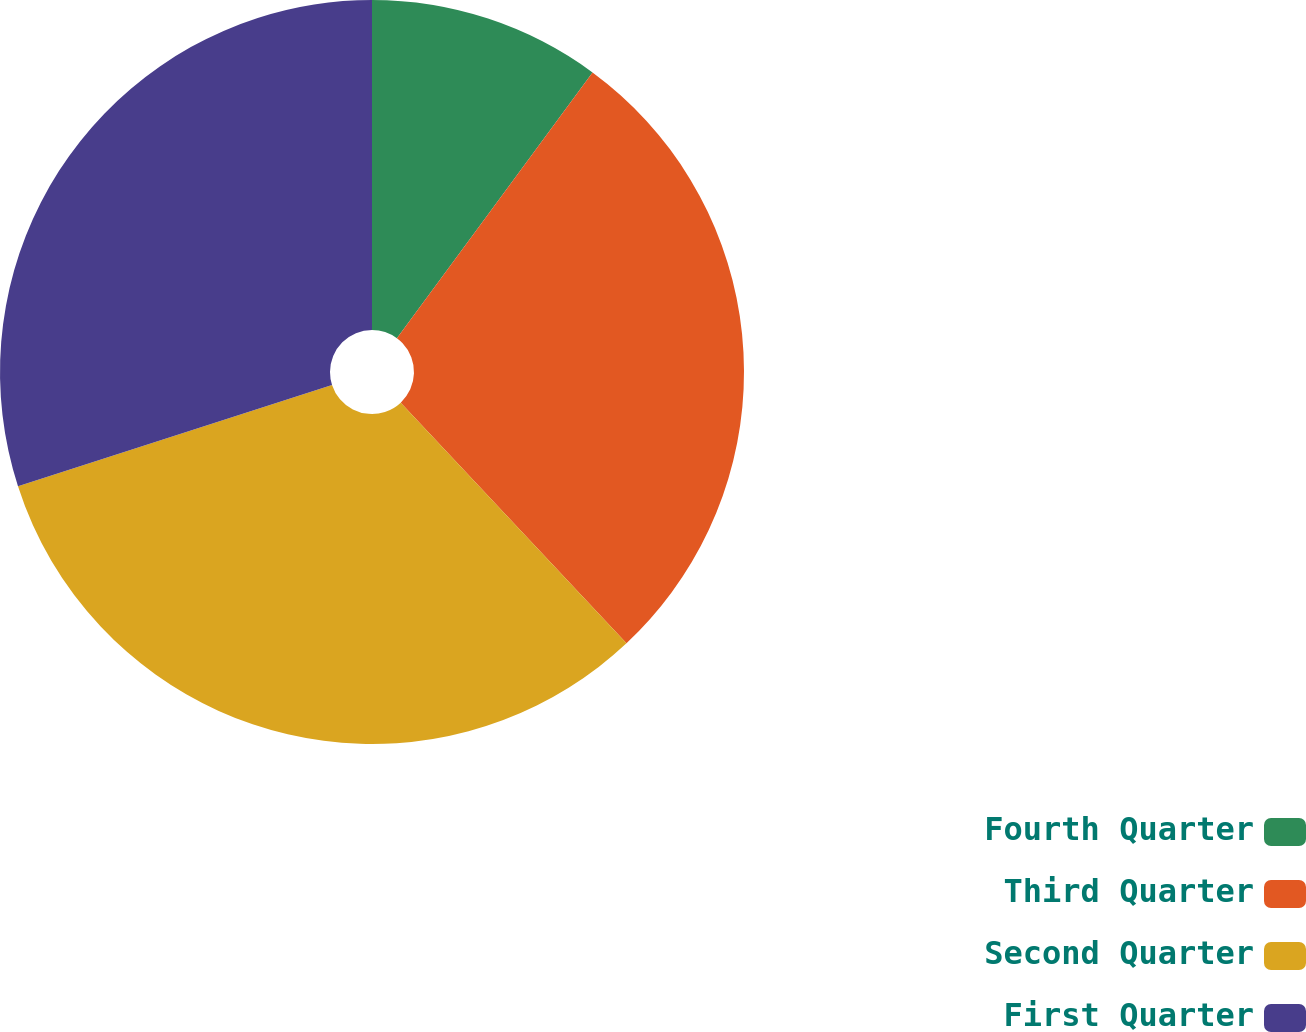<chart> <loc_0><loc_0><loc_500><loc_500><pie_chart><fcel>Fourth Quarter<fcel>Third Quarter<fcel>Second Quarter<fcel>First Quarter<nl><fcel>10.1%<fcel>27.91%<fcel>32.02%<fcel>29.97%<nl></chart> 